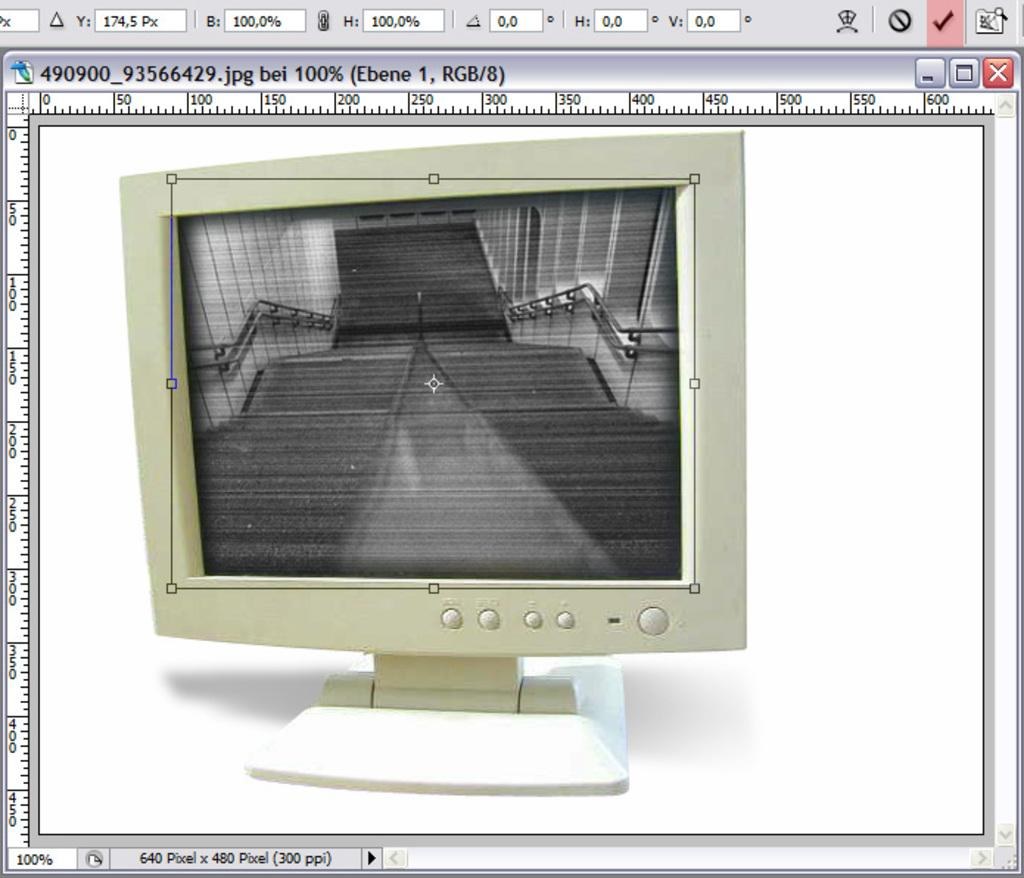Provide a one-sentence caption for the provided image. A photo of a computer Monitor that says it is 640 Pixel x 400 Pixels. 